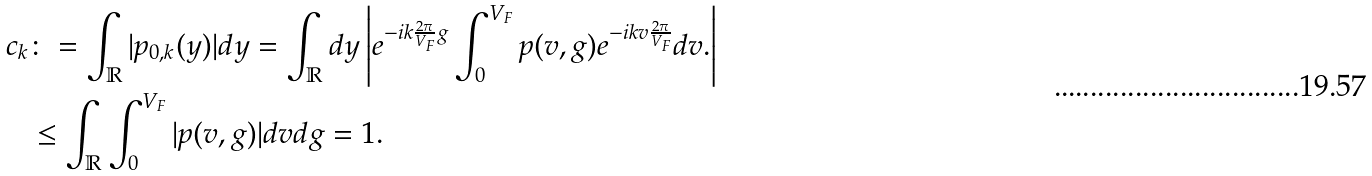<formula> <loc_0><loc_0><loc_500><loc_500>c _ { k } & \colon = \int _ { \mathbb { R } } | p _ { 0 , k } ( y ) | d y = \int _ { \mathbb { R } } d y \left | e ^ { - i k \frac { 2 \pi } { V _ { F } } g } \int _ { 0 } ^ { V _ { F } } p ( v , g ) e ^ { - i k v \frac { 2 \pi } { V _ { F } } } d v . \right | \\ & \leq \int _ { \mathbb { R } } \int _ { 0 } ^ { V _ { F } } | p ( v , g ) | d v d g = 1 .</formula> 